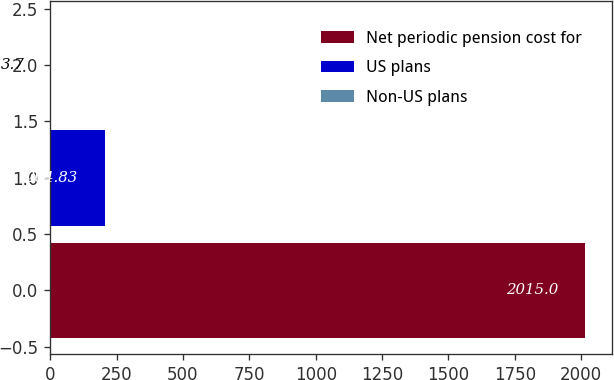Convert chart. <chart><loc_0><loc_0><loc_500><loc_500><bar_chart><fcel>Net periodic pension cost for<fcel>US plans<fcel>Non-US plans<nl><fcel>2015<fcel>204.83<fcel>3.7<nl></chart> 